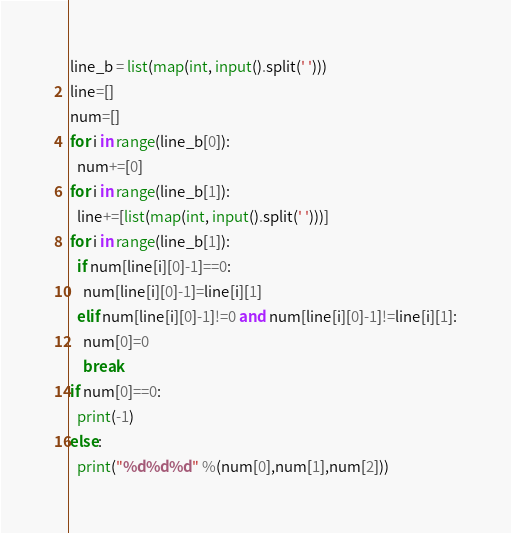<code> <loc_0><loc_0><loc_500><loc_500><_Python_>line_b = list(map(int, input().split(' ')))
line=[]
num=[]
for i in range(line_b[0]):
  num+=[0]
for i in range(line_b[1]):
  line+=[list(map(int, input().split(' ')))]
for i in range(line_b[1]):
  if num[line[i][0]-1]==0:
    num[line[i][0]-1]=line[i][1]
  elif num[line[i][0]-1]!=0 and num[line[i][0]-1]!=line[i][1]:
    num[0]=0
    break
if num[0]==0:
  print(-1)
else:
  print("%d%d%d" %(num[0],num[1],num[2]))</code> 